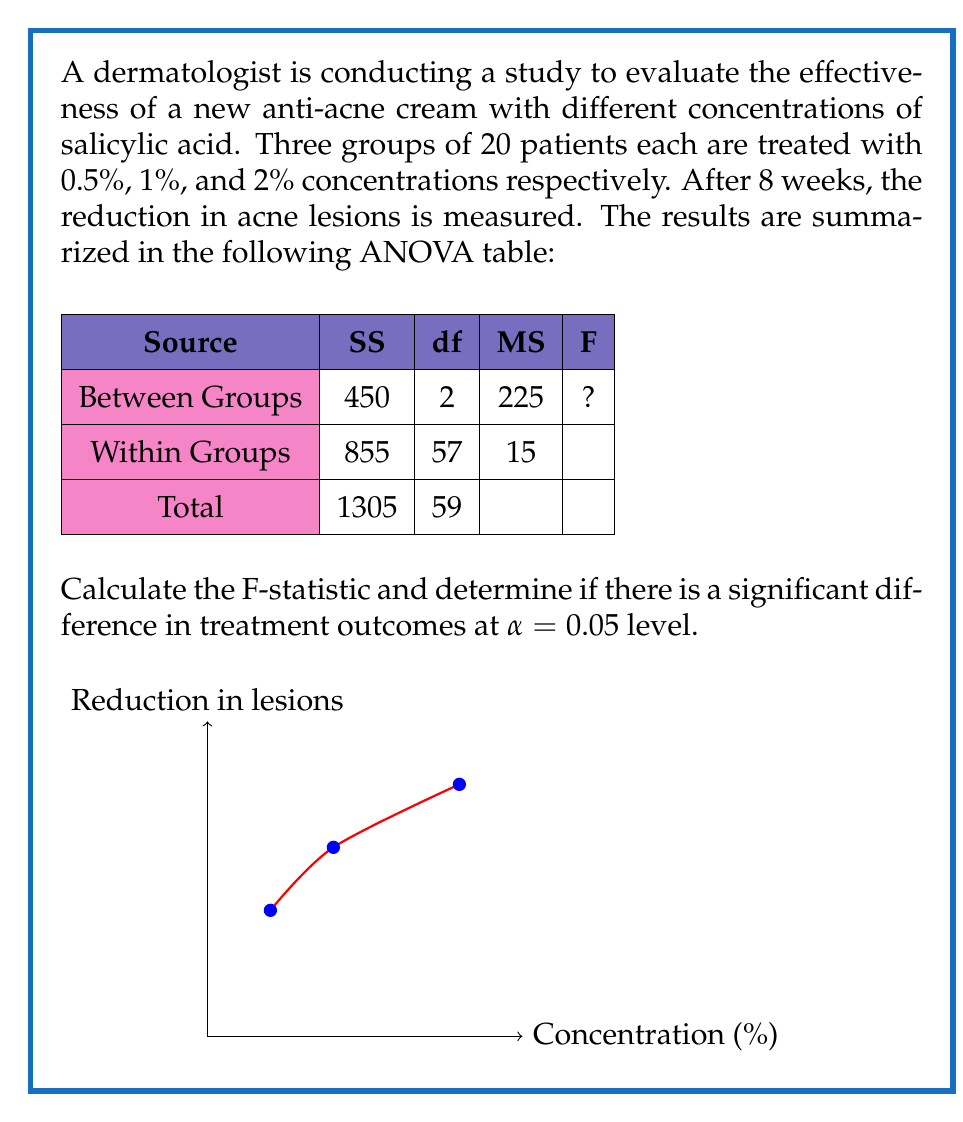Provide a solution to this math problem. To solve this problem, we'll follow these steps:

1) First, let's calculate the F-statistic:

   The F-statistic is calculated as:

   $$F = \frac{\text{MS}_\text{Between}}{\text{MS}_\text{Within}}$$

   We're given:
   $$\text{MS}_\text{Between} = 225$$
   $$\text{MS}_\text{Within} = 15$$

   So:
   $$F = \frac{225}{15} = 15$$

2) Now, we need to determine if this F-value is significant at α = 0.05 level.

3) To do this, we need to find the critical F-value from the F-distribution table.

4) The degrees of freedom for the numerator (between groups) is 2, and for the denominator (within groups) is 57.

5) Looking up these values in an F-table for α = 0.05, we find:

   $$F_\text{critical}(2,57) ≈ 3.16$$

6) Since our calculated F-value (15) is greater than the critical F-value (3.16), we reject the null hypothesis.

7) This means there is a statistically significant difference in treatment outcomes among the different concentrations of salicylic acid.
Answer: F = 15; Significant difference at α = 0.05 